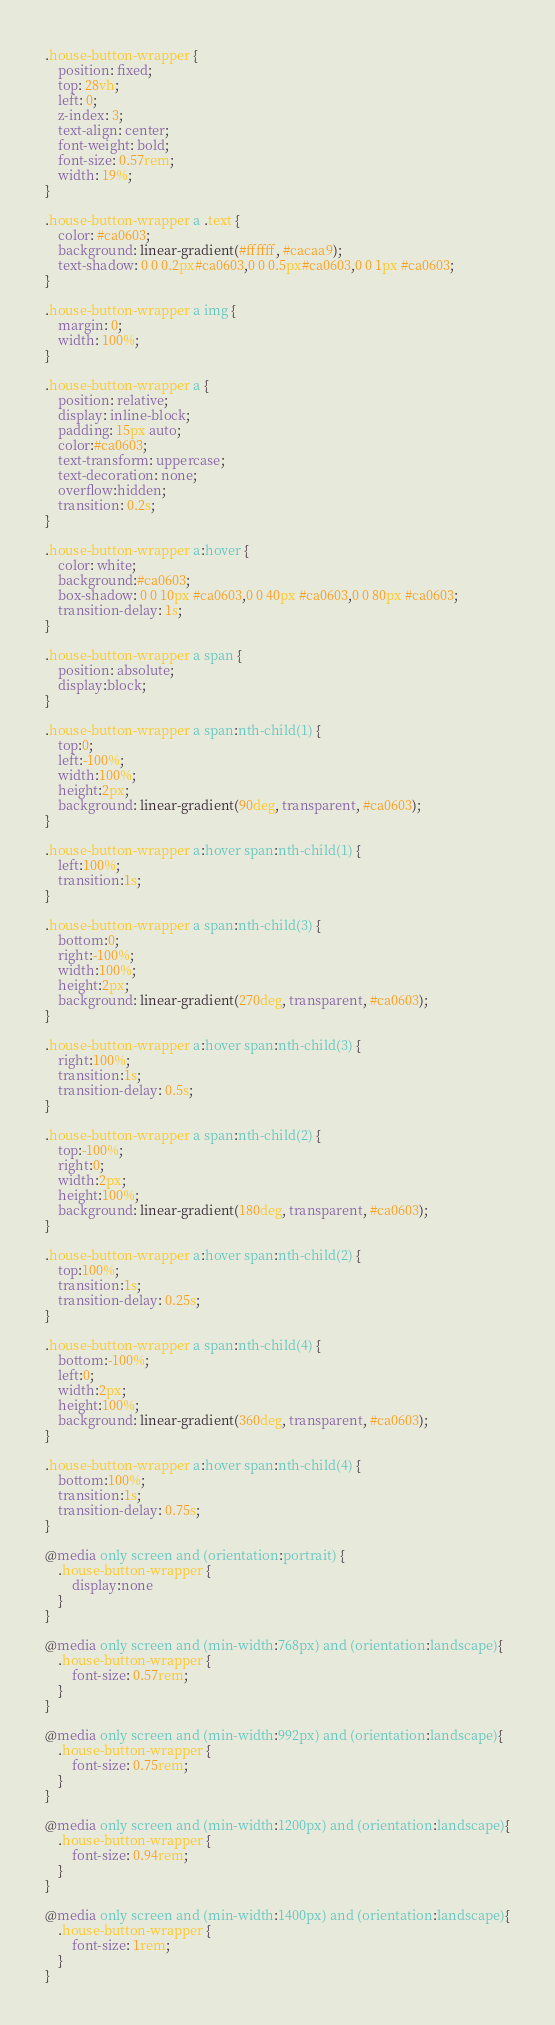Convert code to text. <code><loc_0><loc_0><loc_500><loc_500><_CSS_>.house-button-wrapper {
    position: fixed;
    top: 28vh;
    left: 0;
    z-index: 3;
    text-align: center;
    font-weight: bold;
    font-size: 0.57rem;
    width: 19%;
}

.house-button-wrapper a .text {
    color: #ca0603;
    background: linear-gradient(#ffffff, #cacaa9);
    text-shadow: 0 0 0.2px#ca0603,0 0 0.5px#ca0603,0 0 1px #ca0603;
}

.house-button-wrapper a img {
    margin: 0;
    width: 100%;
}

.house-button-wrapper a {
    position: relative;
    display: inline-block;
    padding: 15px auto;
    color:#ca0603;
    text-transform: uppercase;
    text-decoration: none;
    overflow:hidden;
    transition: 0.2s;
}

.house-button-wrapper a:hover {
    color: white;
    background:#ca0603;
    box-shadow: 0 0 10px #ca0603,0 0 40px #ca0603,0 0 80px #ca0603;
    transition-delay: 1s;
}

.house-button-wrapper a span {
    position: absolute;
    display:block;
}

.house-button-wrapper a span:nth-child(1) {
    top:0;
    left:-100%;
    width:100%;
    height:2px;
    background: linear-gradient(90deg, transparent, #ca0603);
}

.house-button-wrapper a:hover span:nth-child(1) {
    left:100%;
    transition:1s;
}

.house-button-wrapper a span:nth-child(3) {
    bottom:0;
    right:-100%;
    width:100%;
    height:2px;
    background: linear-gradient(270deg, transparent, #ca0603);
}

.house-button-wrapper a:hover span:nth-child(3) {
    right:100%;
    transition:1s;
    transition-delay: 0.5s;
}

.house-button-wrapper a span:nth-child(2) {
    top:-100%;
    right:0;
    width:2px;
    height:100%;
    background: linear-gradient(180deg, transparent, #ca0603);
}

.house-button-wrapper a:hover span:nth-child(2) {
    top:100%;
    transition:1s;
    transition-delay: 0.25s;
}

.house-button-wrapper a span:nth-child(4) {
    bottom:-100%;
    left:0;
    width:2px;
    height:100%;
    background: linear-gradient(360deg, transparent, #ca0603);
}

.house-button-wrapper a:hover span:nth-child(4) {
    bottom:100%;
    transition:1s;
    transition-delay: 0.75s;
}

@media only screen and (orientation:portrait) {
    .house-button-wrapper {
        display:none
    }
}

@media only screen and (min-width:768px) and (orientation:landscape){
    .house-button-wrapper {
        font-size: 0.57rem;
    }
}

@media only screen and (min-width:992px) and (orientation:landscape){
    .house-button-wrapper {
        font-size: 0.75rem;
    }
}

@media only screen and (min-width:1200px) and (orientation:landscape){
    .house-button-wrapper {
        font-size: 0.94rem;
    }
}

@media only screen and (min-width:1400px) and (orientation:landscape){
    .house-button-wrapper {
        font-size: 1rem;
    }
}

</code> 